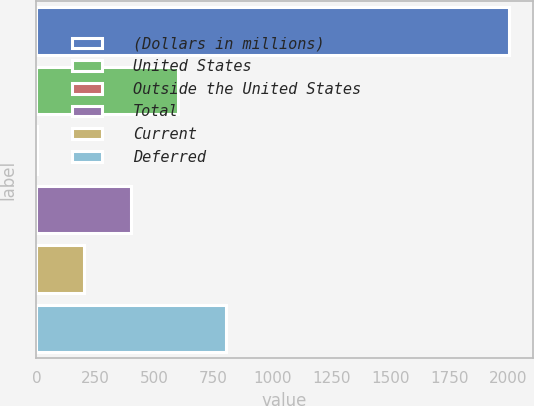Convert chart to OTSL. <chart><loc_0><loc_0><loc_500><loc_500><bar_chart><fcel>(Dollars in millions)<fcel>United States<fcel>Outside the United States<fcel>Total<fcel>Current<fcel>Deferred<nl><fcel>2004<fcel>601.9<fcel>1<fcel>401.6<fcel>201.3<fcel>802.2<nl></chart> 